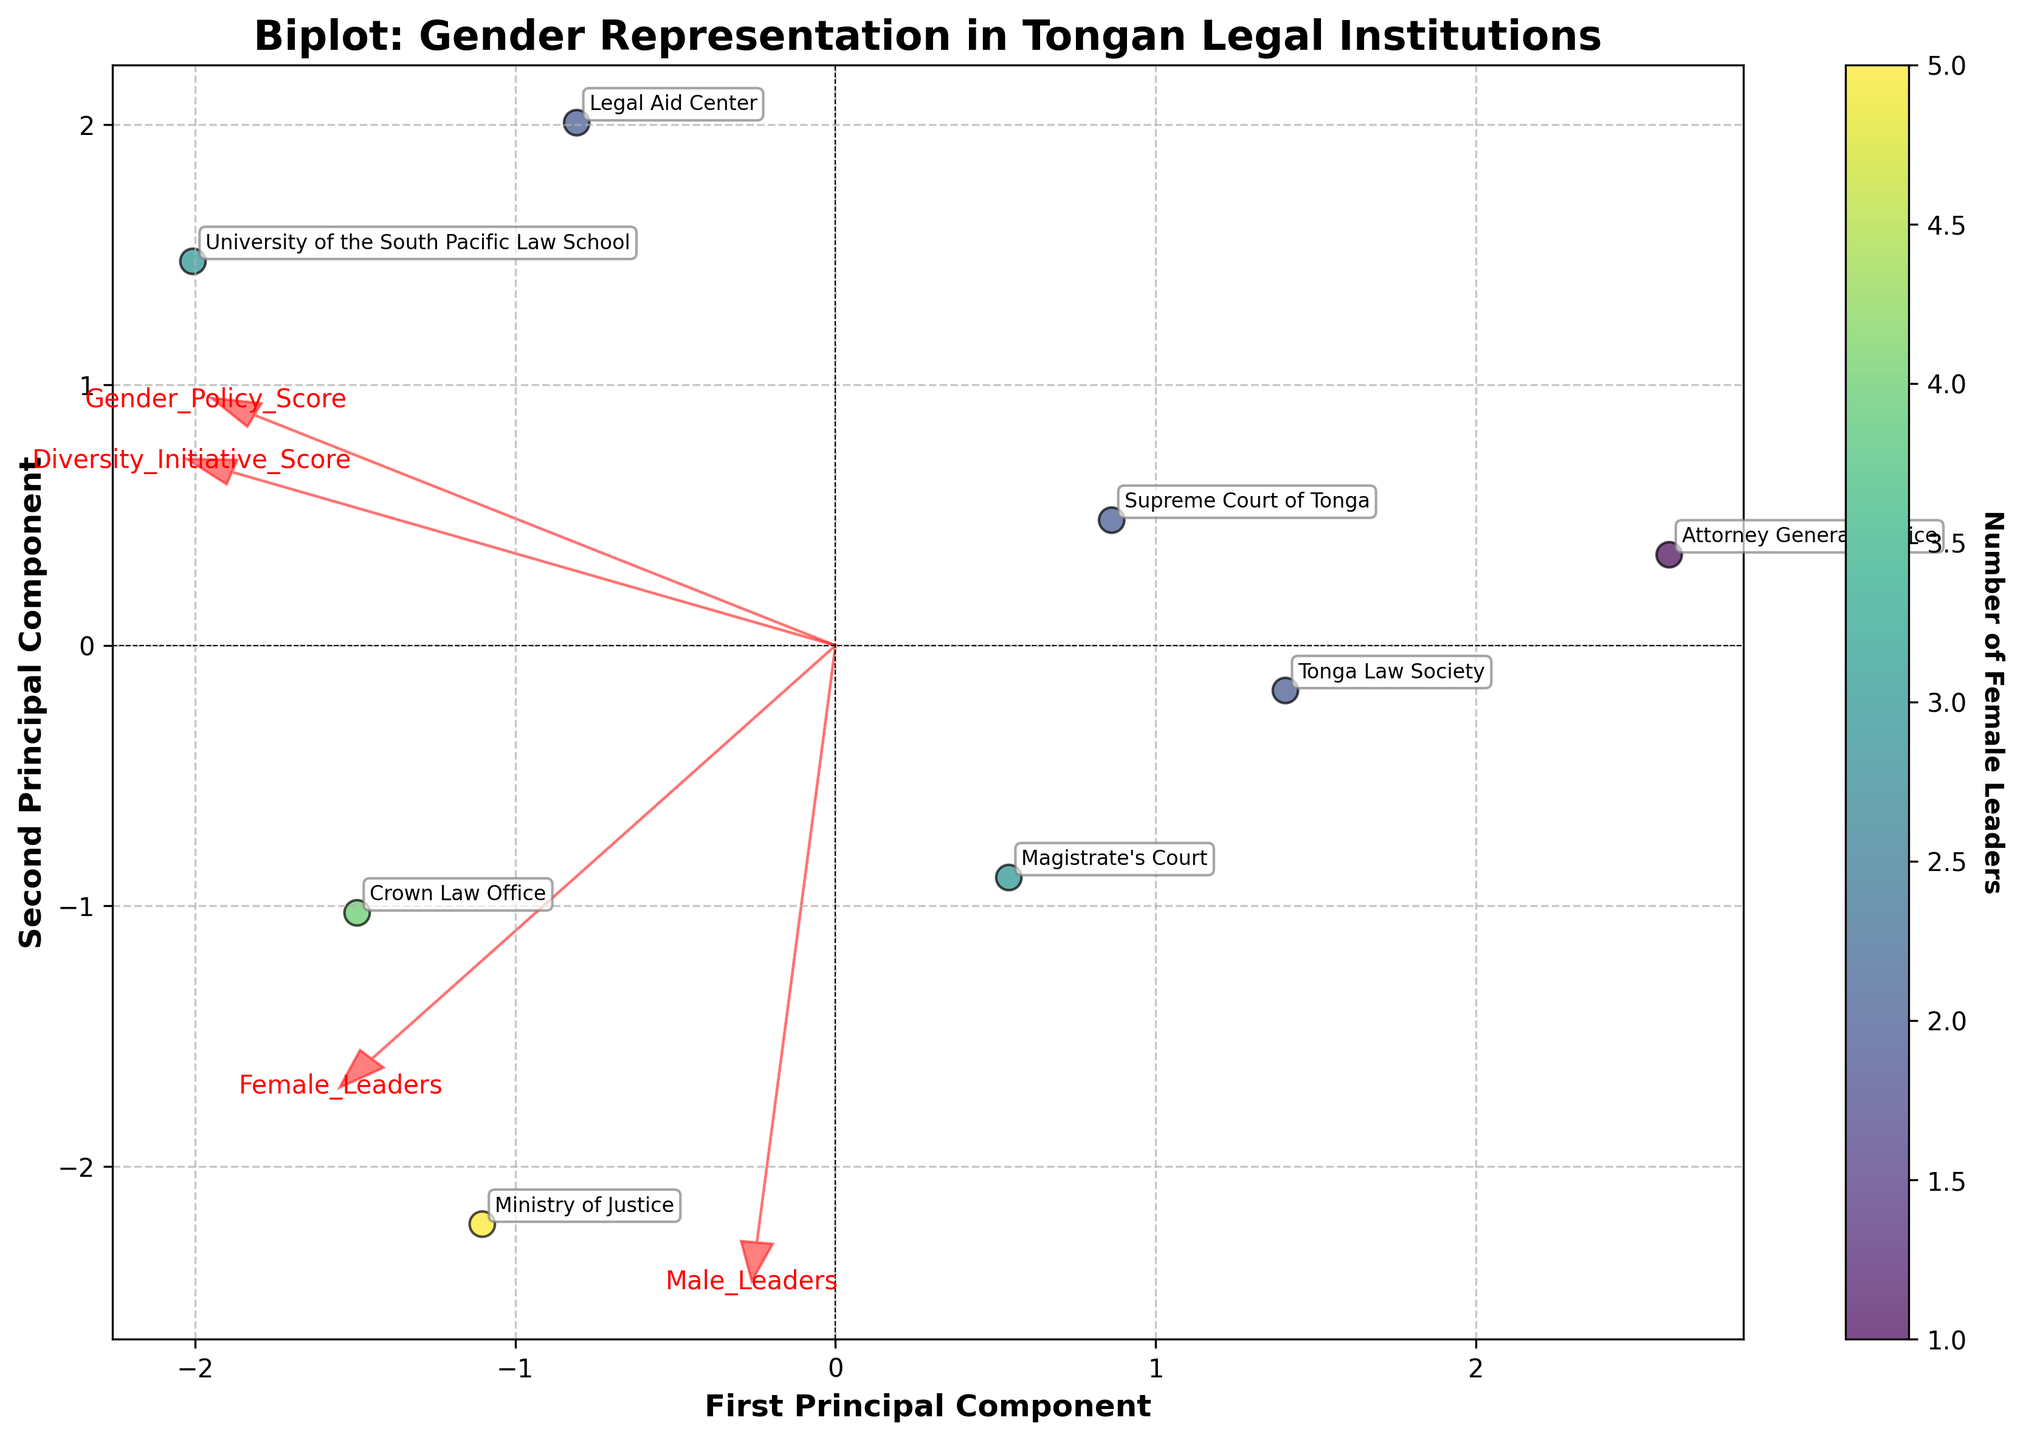What is the title of the figure? The title of the figure is located at the top and usually provides a summary or the main focus of the figure. In this case, the title is 'Biplot: Gender Representation in Tongan Legal Institutions.'
Answer: Biplot: Gender Representation in Tongan Legal Institutions How many leaders are there in the University of the South Pacific Law School? The plot annotates each institution clearly. Look specifically for the tag for University of the South Pacific Law School and refer to the data point it labels, which shows there are 3 female leaders and 2 male leaders.
Answer: 5 Which institution has the highest number of female leaders based on the color of the scatter points? The color intensity on the scatter points indicates the number of female leaders. Look for the point with the deepest color, which is labeled and represents the Ministry of Justice.
Answer: Ministry of Justice Which axis corresponds to the first principal component? The first principal component is usually indicated on the horizontal axis in most PCA plots. Here, the x-axis is labeled 'First Principal Component.'
Answer: Horizontal axis Which variable vector points more strongly towards the first principal component, “Female Leaders” or “Gender Policy Score"? By examining the directional arrows representing variable vectors, compare their alignment with the first principal component axis. The "Female Leaders" vector points more strongly along this component.
Answer: Female Leaders Compare the gender diversity initiative score between the Supreme Court of Tonga and Crown Law Office. Which one has a higher score? Look for the directional arrows and where the data points for these two institutions lie relative to the "Diversity_Initiative_Score" vector. Compare their positions along this vector. Crown Law Office is positioned higher.
Answer: Crown Law Office What is the range of the first principal component values? Observing the horizontal axis, note the minimum value (close to -2.5) and maximum value (close to 2.5) of the first principal component. The range can be calculated as the difference between these two values.
Answer: ~5 Which institution is closest to the origin of the biplot? Identify the point closest to where the x-axis and y-axis intersect, which is the origin. The closest labeled point to this intersection is the Legal Aid Center.
Answer: Legal Aid Center Compare the number of male leaders in the Ministry of Justice and the Legal Aid Center. Which one has more? Check the annotated points for these two institutions and refer to their respective male leader counts. Ministry of Justice has 7 male leaders, while Legal Aid Center has 1.
Answer: Ministry of Justice 